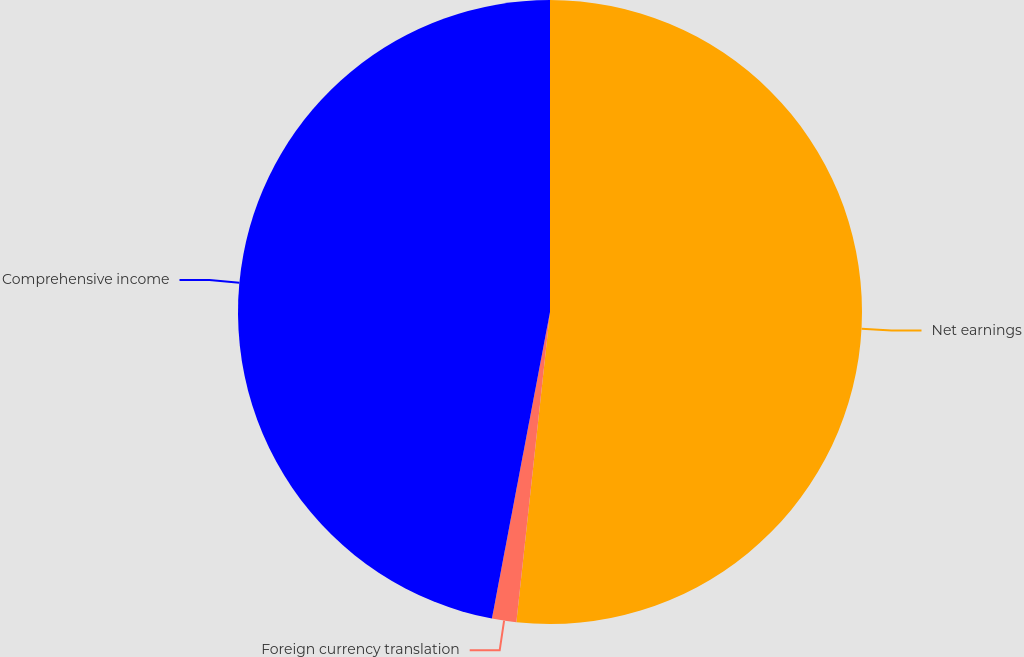Convert chart. <chart><loc_0><loc_0><loc_500><loc_500><pie_chart><fcel>Net earnings<fcel>Foreign currency translation<fcel>Comprehensive income<nl><fcel>51.72%<fcel>1.26%<fcel>47.02%<nl></chart> 